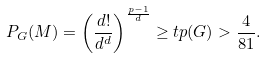Convert formula to latex. <formula><loc_0><loc_0><loc_500><loc_500>P _ { G } ( M ) = \left ( \frac { d ! } { d ^ { d } } \right ) ^ { \frac { p - 1 } { d } } \geq t p ( G ) > \frac { 4 } { 8 1 } .</formula> 